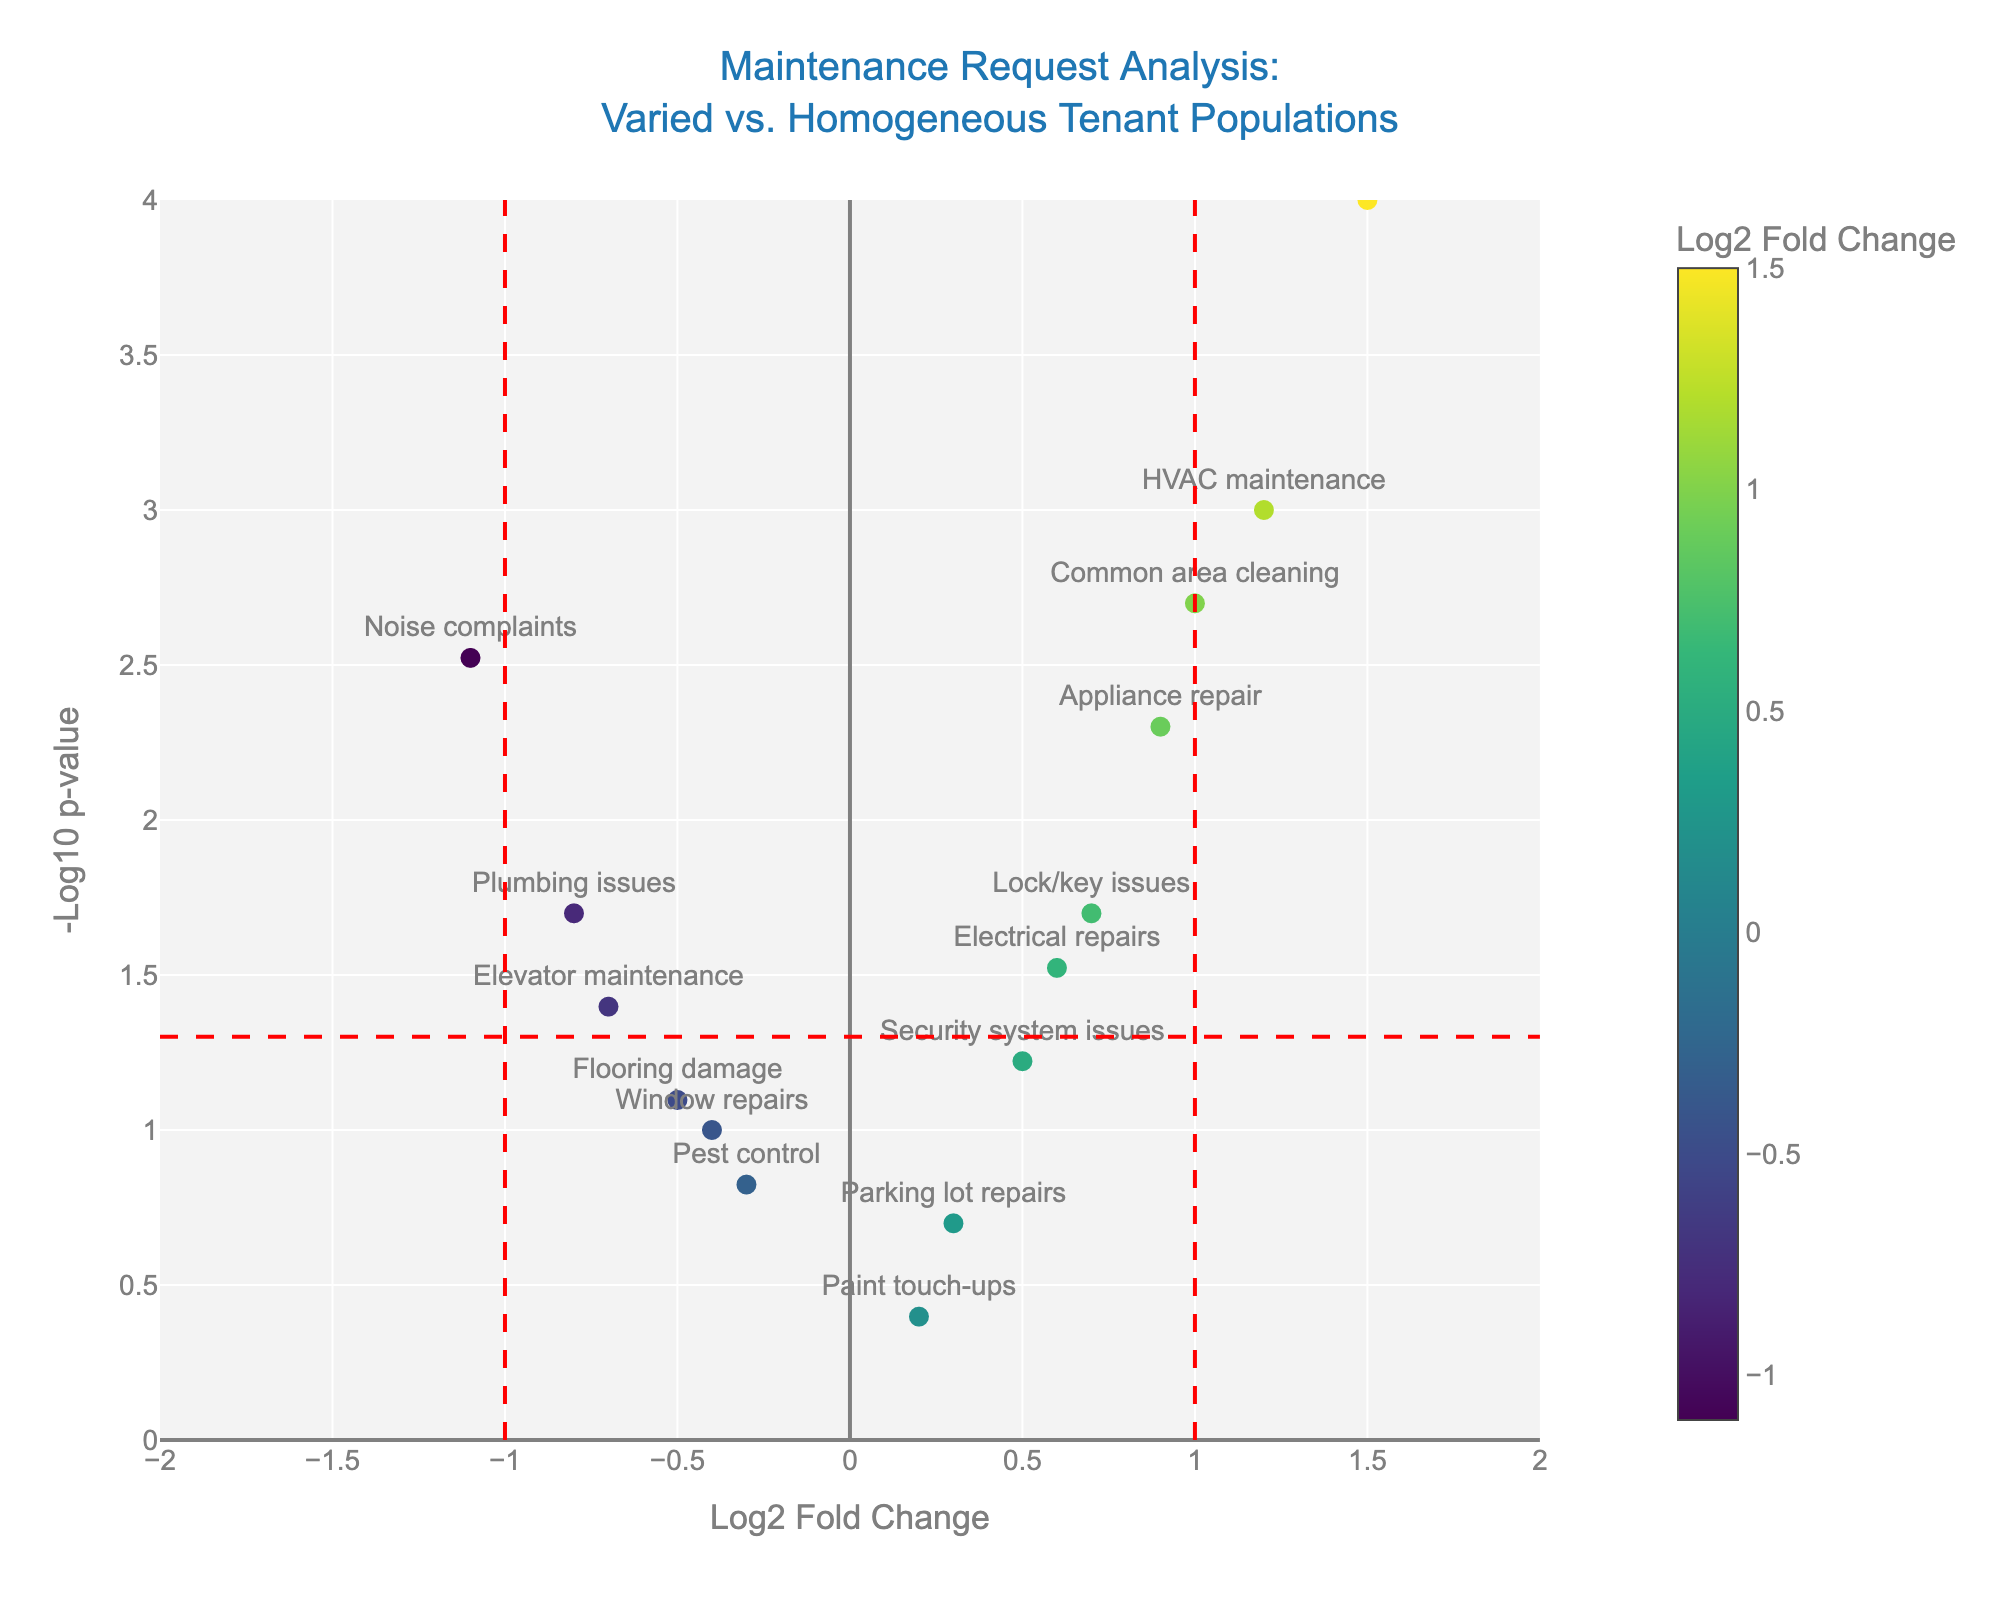What's the title of the figure? The title is usually positioned at the top center of the figure and is displayed in a larger font size for emphasis. In this case, it describes the subject of the plot.
Answer: Maintenance Request Analysis: Varied vs. Homogeneous Tenant Populations How many maintenance request types are plotted? Each maintenance request type is represented by a data point in the scatter plot. The number of points equals the number of maintenance request types.
Answer: 15 Which maintenance request has the highest log2 fold change value? By identifying the data point farthest to the right along the x-axis (log2 fold change), we can find which maintenance request type it represents.
Answer: Landscaping requests What does the vertical red line at x=1 signify? Vertical lines in Volcano Plots often demarcate thresholds for significance. Here, x=1 likely represents a log2 fold change cut-off.
Answer: A significance threshold for log2 fold change Which request type has the lowest p-value? The -log10(p-value) transforms the p-value to make smaller values larger in the plot. A higher point on the y-axis indicates a smaller p-value.
Answer: Landscaping requests Which maintenance requests are significantly different from the null hypothesis with a log2 fold change above zero? Maintenance requests above the horizontal line (-log10(p-value) corresponding to 0.05) and to the right of the vertical line (log2 fold change > 0) are significant with a positive fold change.
Answer: Electrical repairs, HVAC maintenance, Appliance repair, Lock/key issues, Landscaping requests, Common area cleaning How many maintenance requests have a p-value below 0.05 but a log2 fold change below zero? Identify data points above the horizontal line (-log10(p-value) corresponding to 0.05) and to the left of the vertical line (log2 fold change < 0) to count them.
Answer: 3 Describe the significance and fold-change of noise complaints. Locate noise complaints in the plot and determine its position relative to the significance lines and log2 fold change value.
Answer: Significant (p-value < 0.05) and has a negative log2 fold change What color represents a log2 fold change of approximately 0.6? The color of the data points corresponds to the log2 fold change value using the colorscale. Identify the corresponding color for 0.6.
Answer: Yellow-green Which maintenance requests are close to being not significant? Analyze the data points near the threshold lines, particularly those near -log10(p-value) of 1.3 and log2 fold change thresholds.
Answer: Security system issues, Flooring damage, Window repairs 